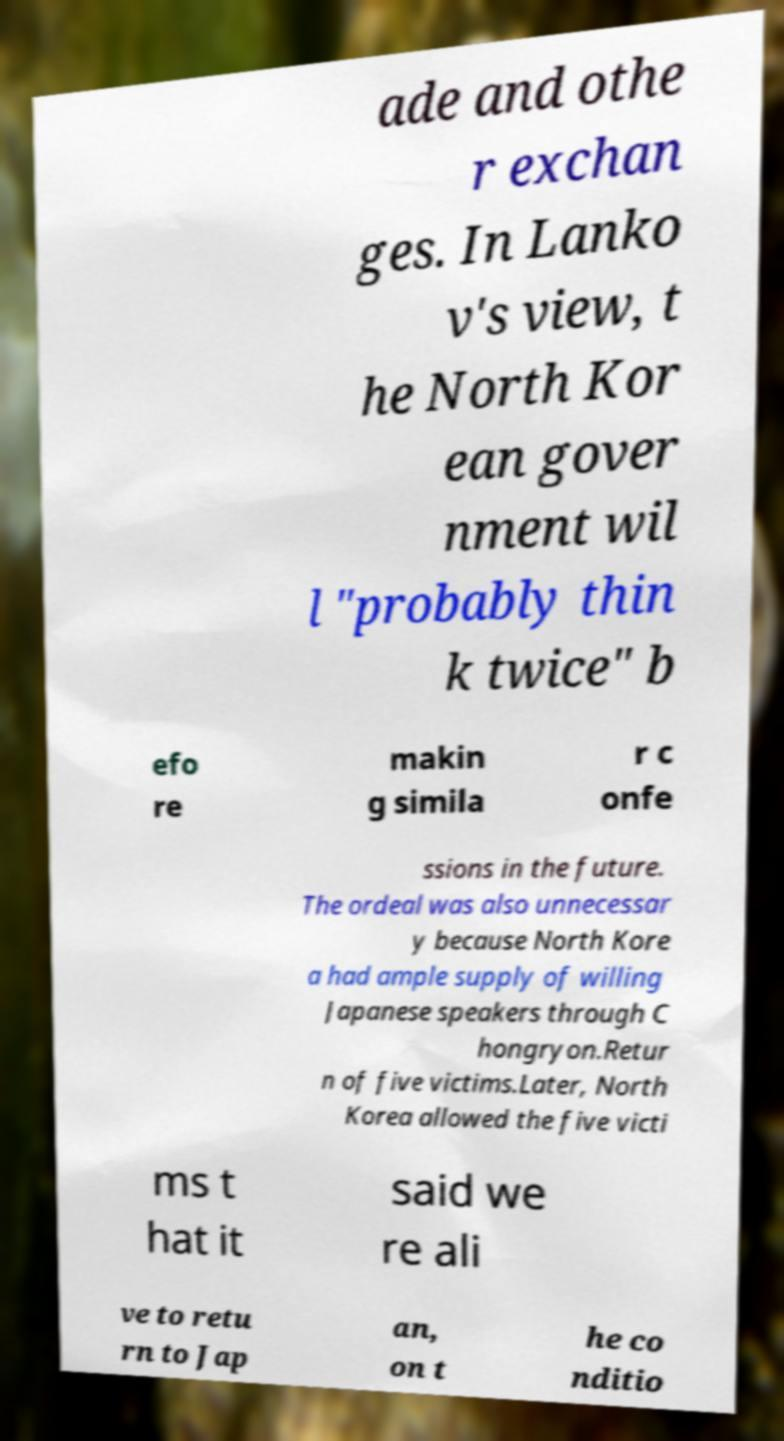For documentation purposes, I need the text within this image transcribed. Could you provide that? ade and othe r exchan ges. In Lanko v's view, t he North Kor ean gover nment wil l "probably thin k twice" b efo re makin g simila r c onfe ssions in the future. The ordeal was also unnecessar y because North Kore a had ample supply of willing Japanese speakers through C hongryon.Retur n of five victims.Later, North Korea allowed the five victi ms t hat it said we re ali ve to retu rn to Jap an, on t he co nditio 